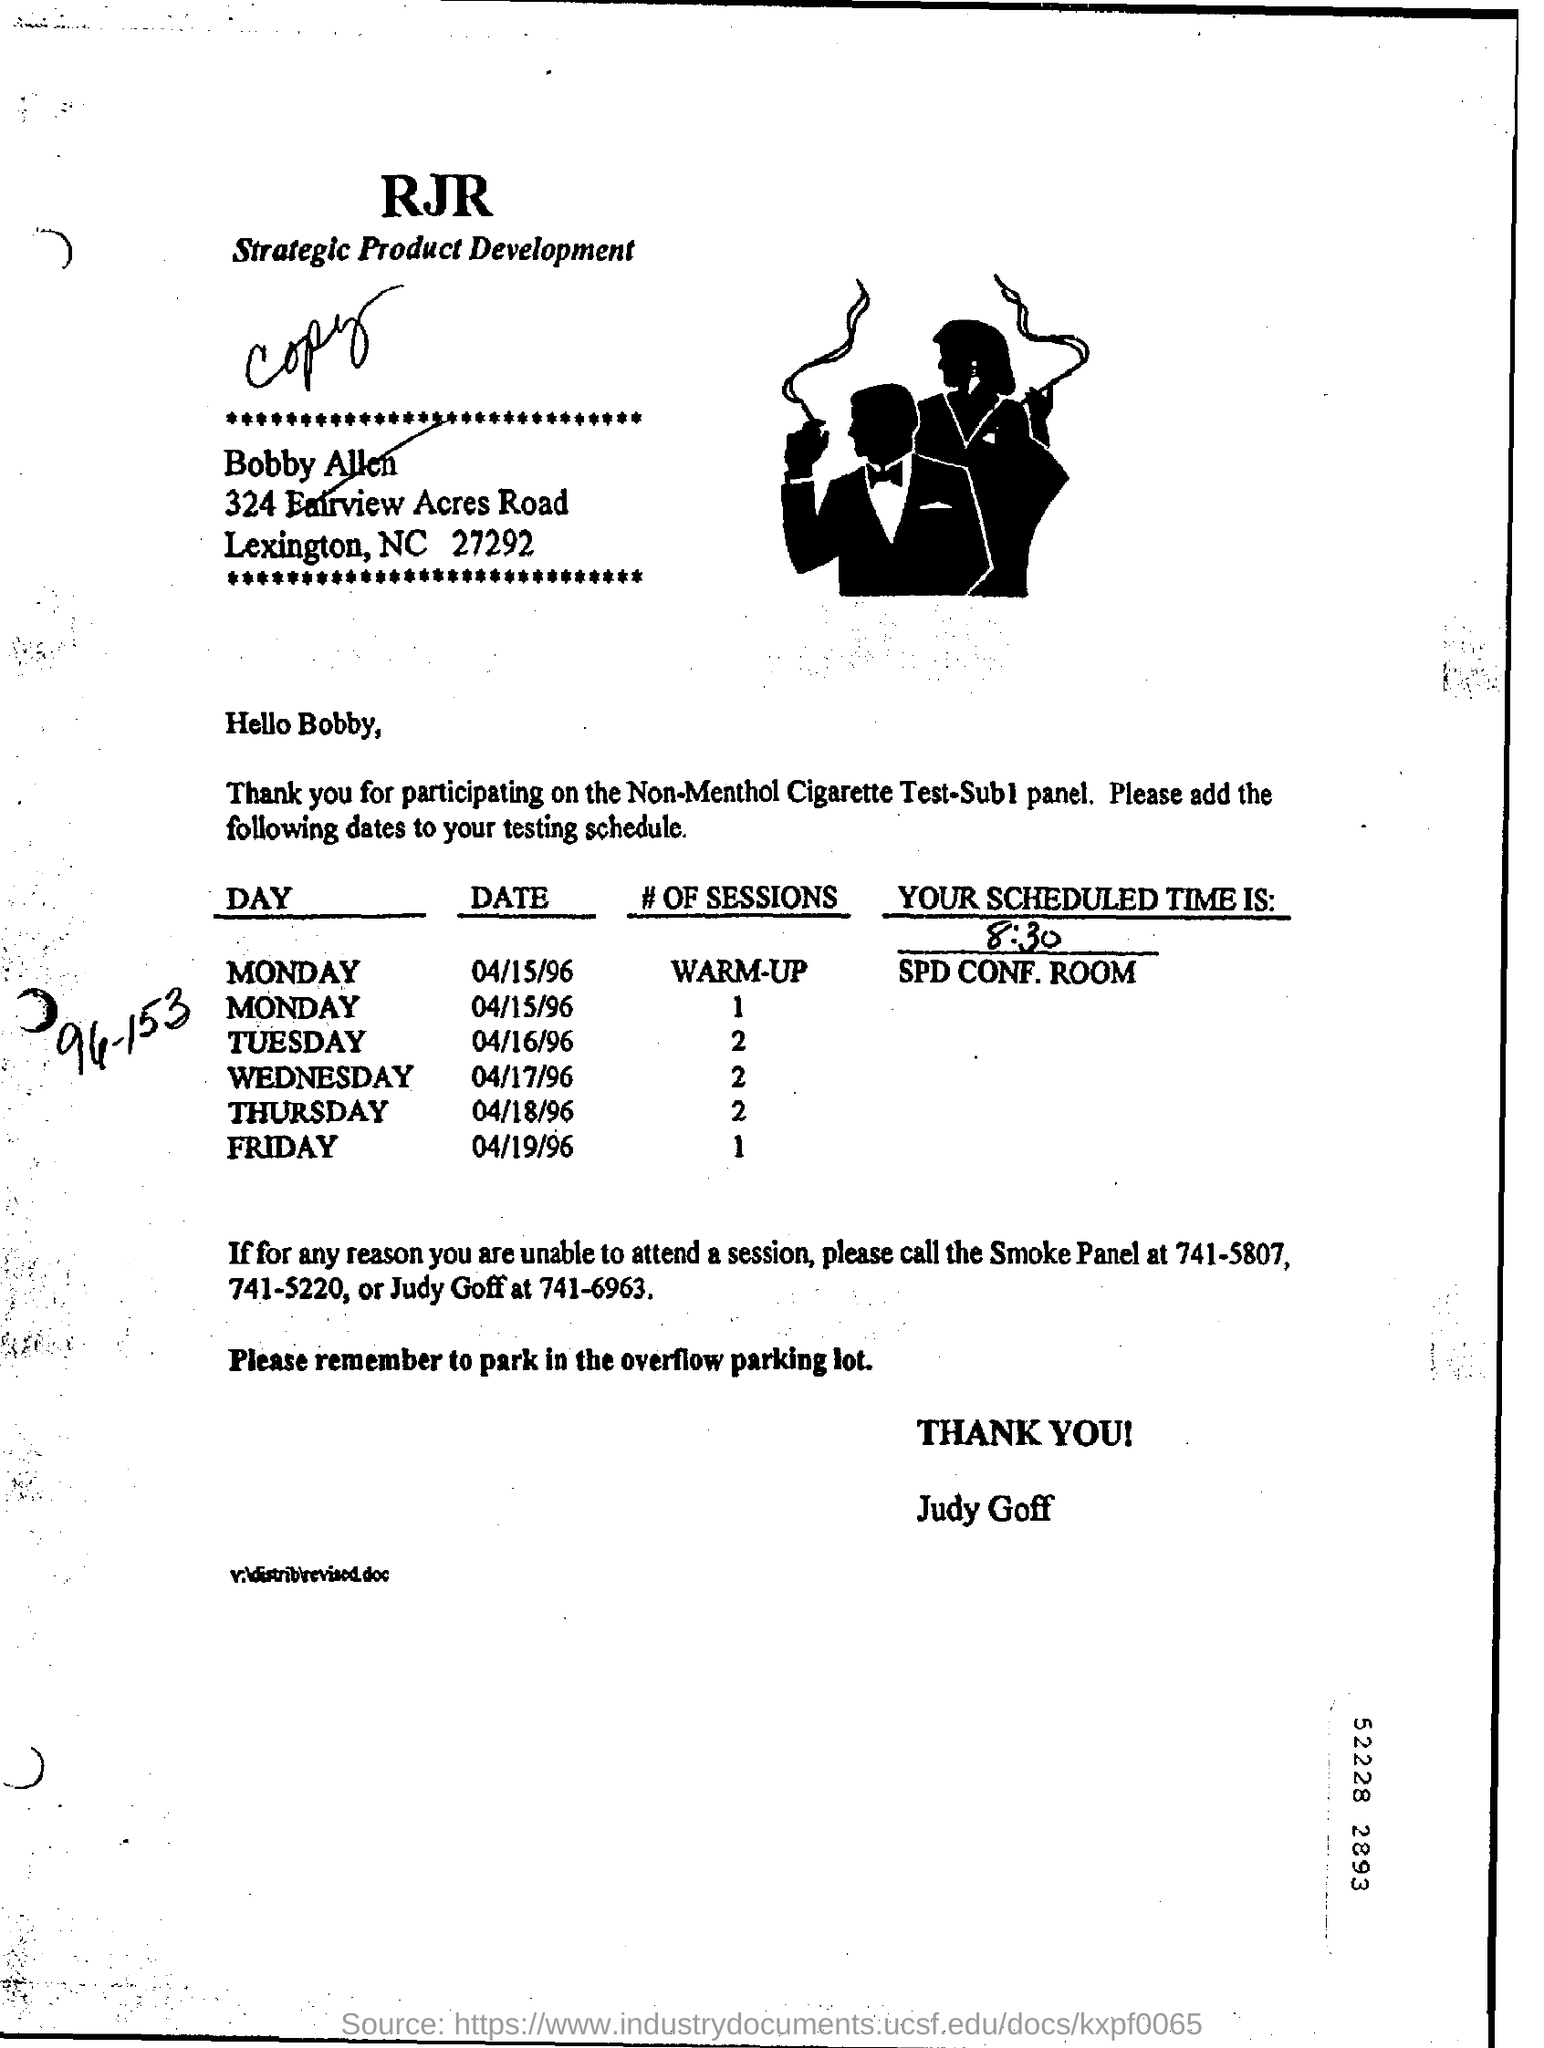Mention a couple of crucial points in this snapshot. I want to know the number of scheduled sessions on Friday. How many sessions are scheduled for Wednesday? On Tuesday, two sessions have been scheduled. The sessions are scheduled in the SPD conference room. On Thursday, the number of scheduled sessions is 2. 